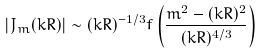Convert formula to latex. <formula><loc_0><loc_0><loc_500><loc_500>| J _ { m } ( k R ) | \sim ( k R ) ^ { - 1 / 3 } f \left ( \frac { m ^ { 2 } - ( k R ) ^ { 2 } } { ( k R ) ^ { 4 / 3 } } \right )</formula> 